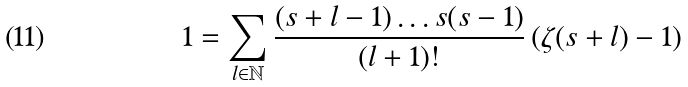<formula> <loc_0><loc_0><loc_500><loc_500>1 = \sum _ { l \in \mathbb { N } } \frac { ( s + l - 1 ) \dots s ( s - 1 ) } { ( l + 1 ) ! } \left ( \zeta ( s + l ) - 1 \right )</formula> 